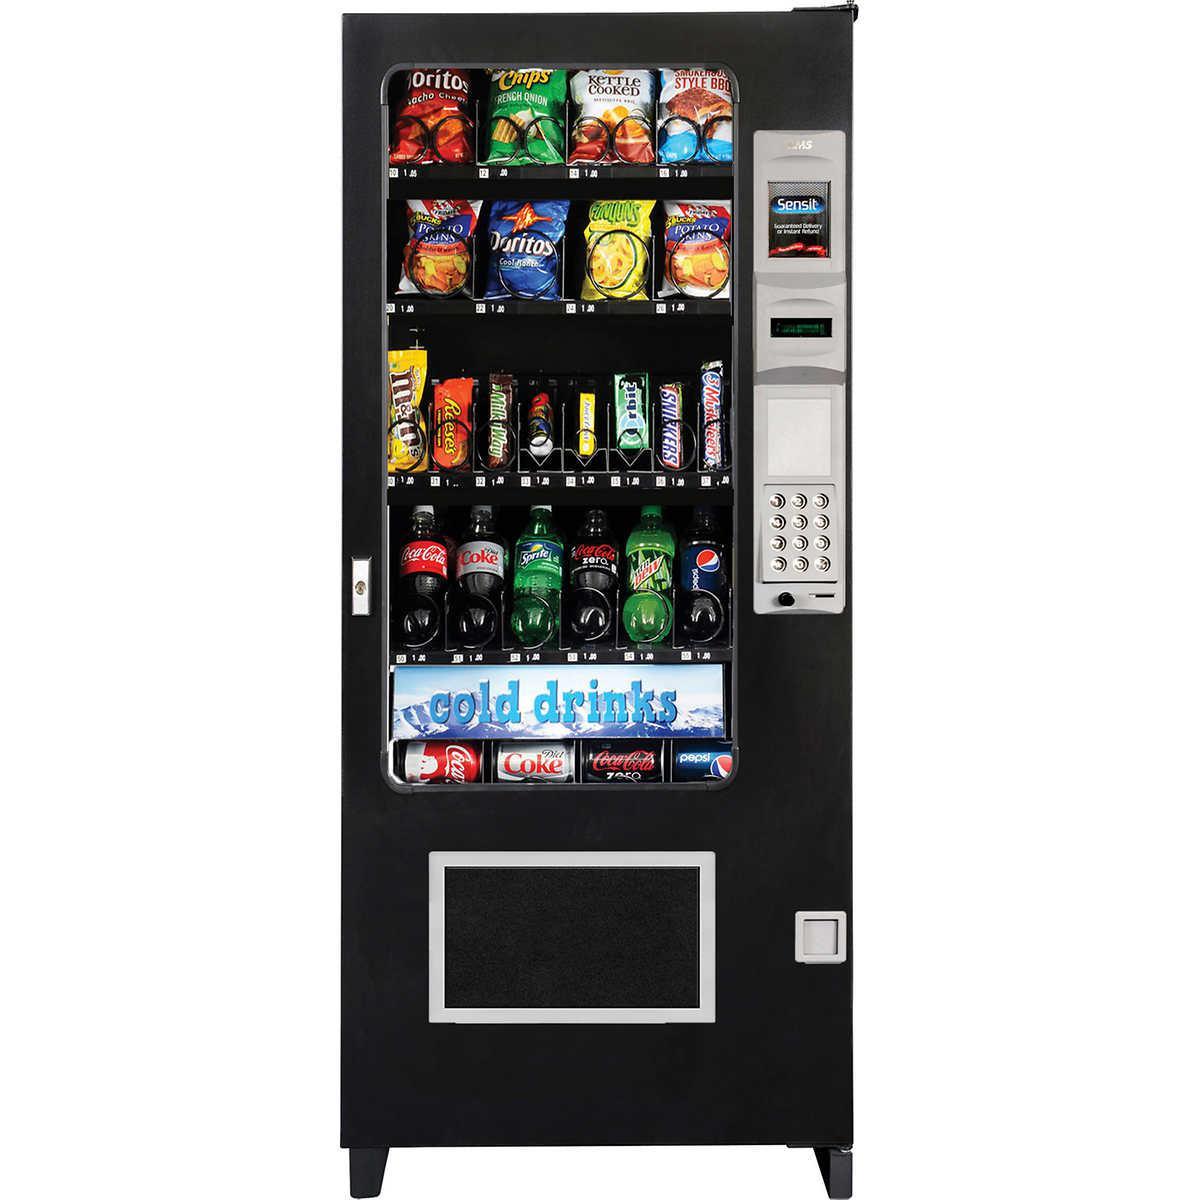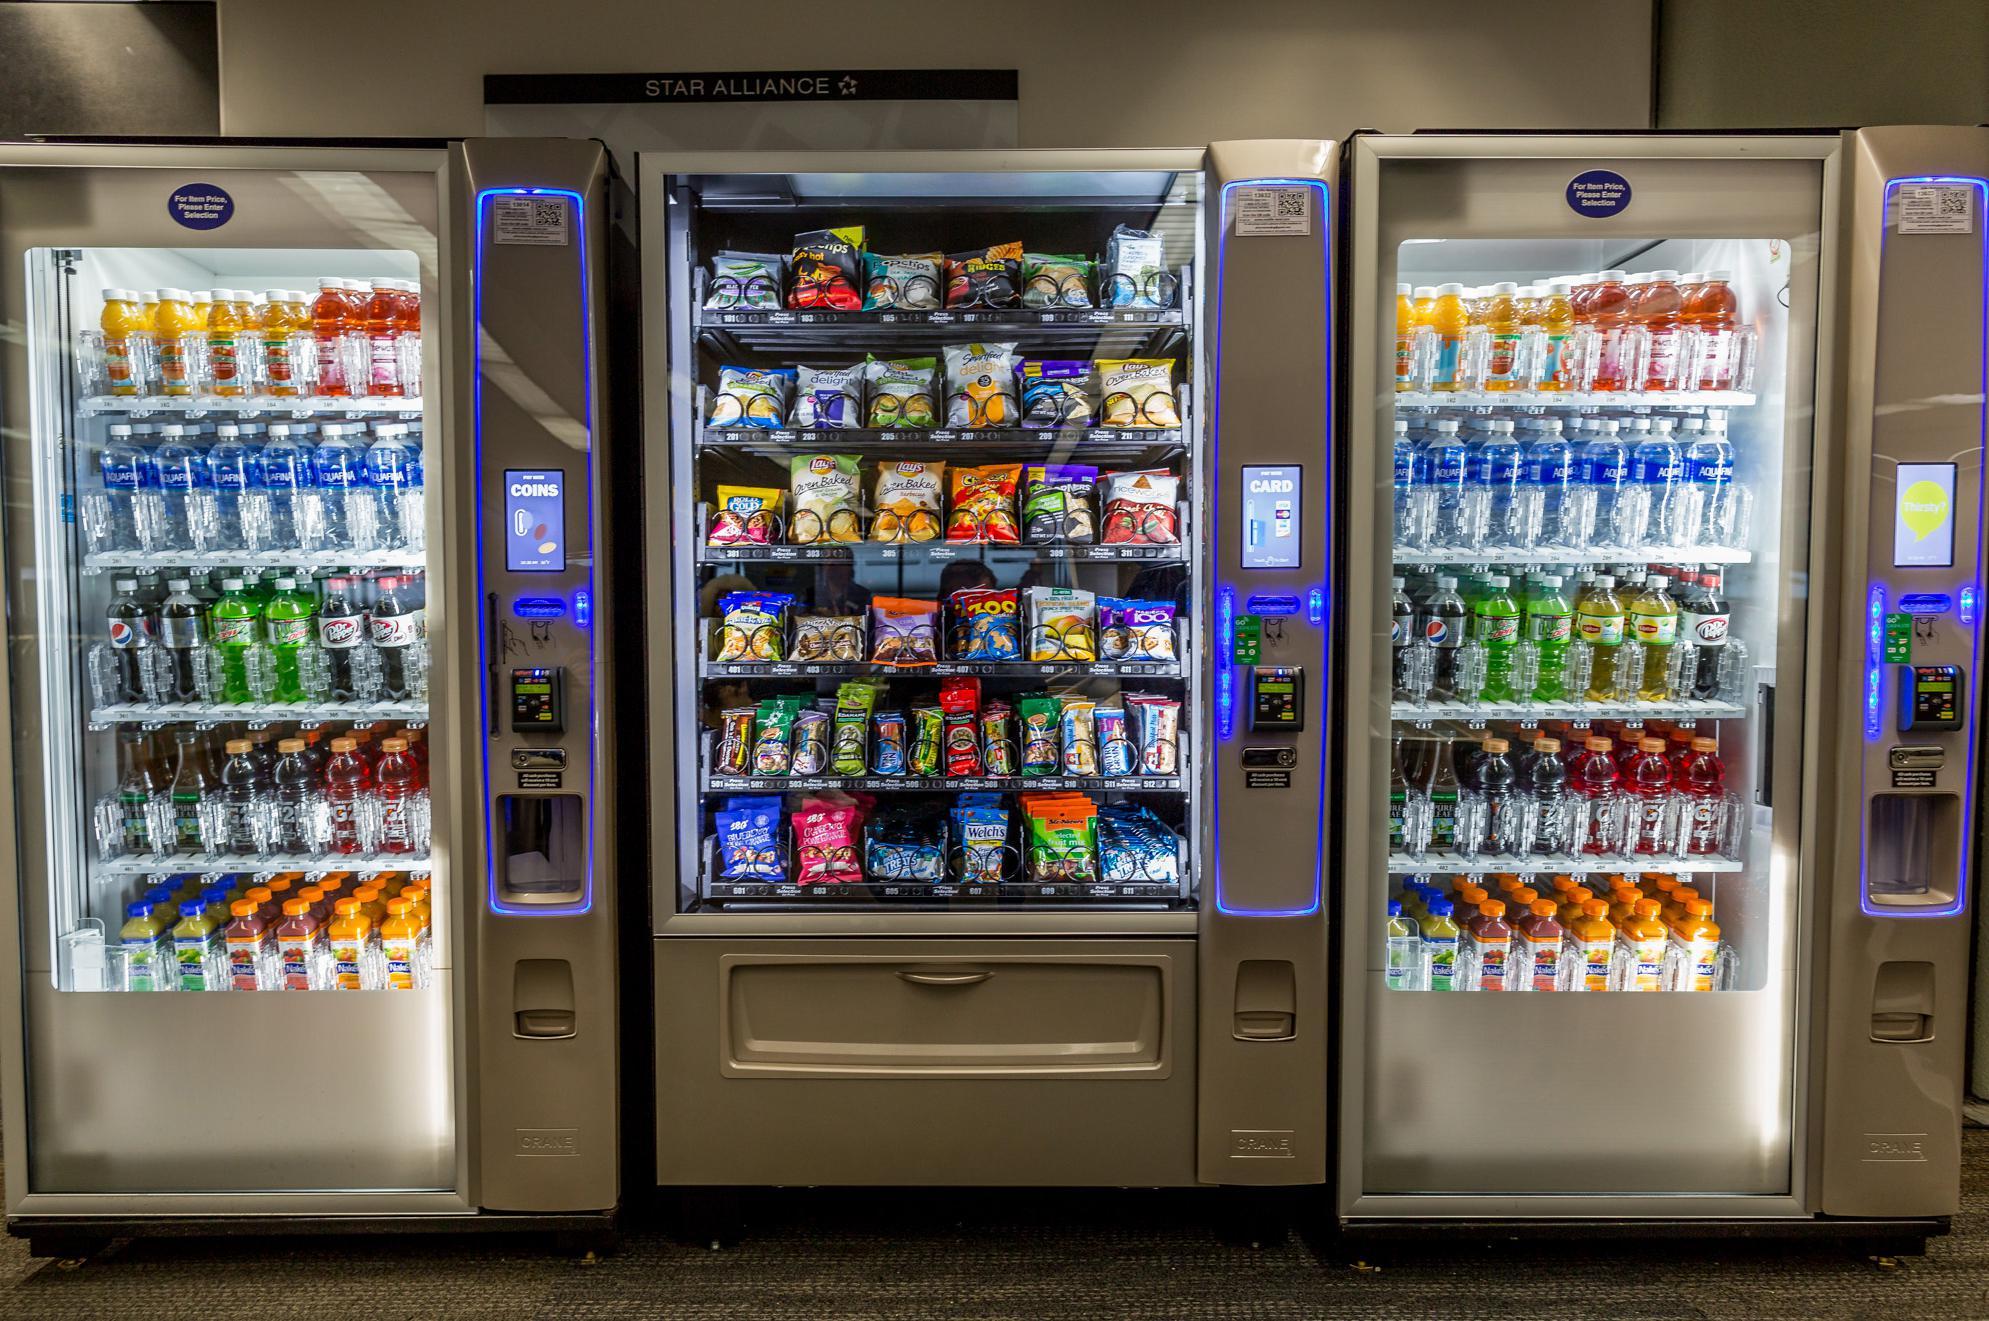The first image is the image on the left, the second image is the image on the right. Considering the images on both sides, is "There are at least three vending machines in the image on the right." valid? Answer yes or no. Yes. 